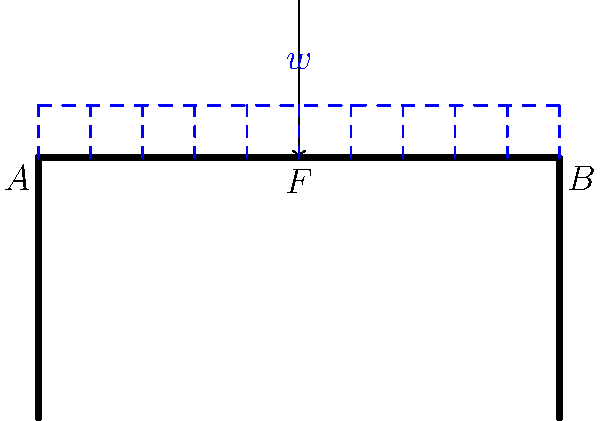A concrete diving platform of length 10 meters is subjected to a uniformly distributed load $w$ and a point load $F$ at its center. If the maximum bending stress at the fixed end (point A) is 15 MPa, what is the value of the distributed load $w$ in kN/m? Assume the platform has a rectangular cross-section with a width of 2 meters and a depth of 0.5 meters. Let's approach this step-by-step:

1) First, we need to calculate the moment of inertia ($I$) of the cross-section:
   $I = \frac{1}{12}bh^3 = \frac{1}{12} \times 2 \times 0.5^3 = 0.0208333$ m⁴

2) The maximum bending stress ($\sigma$) occurs at the outermost fiber, so we use the equation:
   $\sigma = \frac{My}{I}$
   Where $M$ is the bending moment, $y$ is half the depth of the beam.

3) We know $\sigma = 15$ MPa = 15,000,000 Pa, $y = 0.25$ m, so we can find $M$:
   $15,000,000 = \frac{M \times 0.25}{0.0208333}$
   $M = 1250$ kNm

4) Now, we need to set up the equation for the bending moment at point A:
   $M_A = \frac{wL^2}{2} + \frac{FL}{2}$
   Where $L$ is the length of the platform (10 m)

5) We don't know $F$, but we can express it in terms of $w$:
   $F = wL = 10w$

6) Substituting this into our moment equation:
   $1250 = \frac{w \times 10^2}{2} + \frac{10w \times 10}{2}$
   $1250 = 50w + 50w = 100w$

7) Solving for $w$:
   $w = \frac{1250}{100} = 12.5$ kN/m
Answer: 12.5 kN/m 